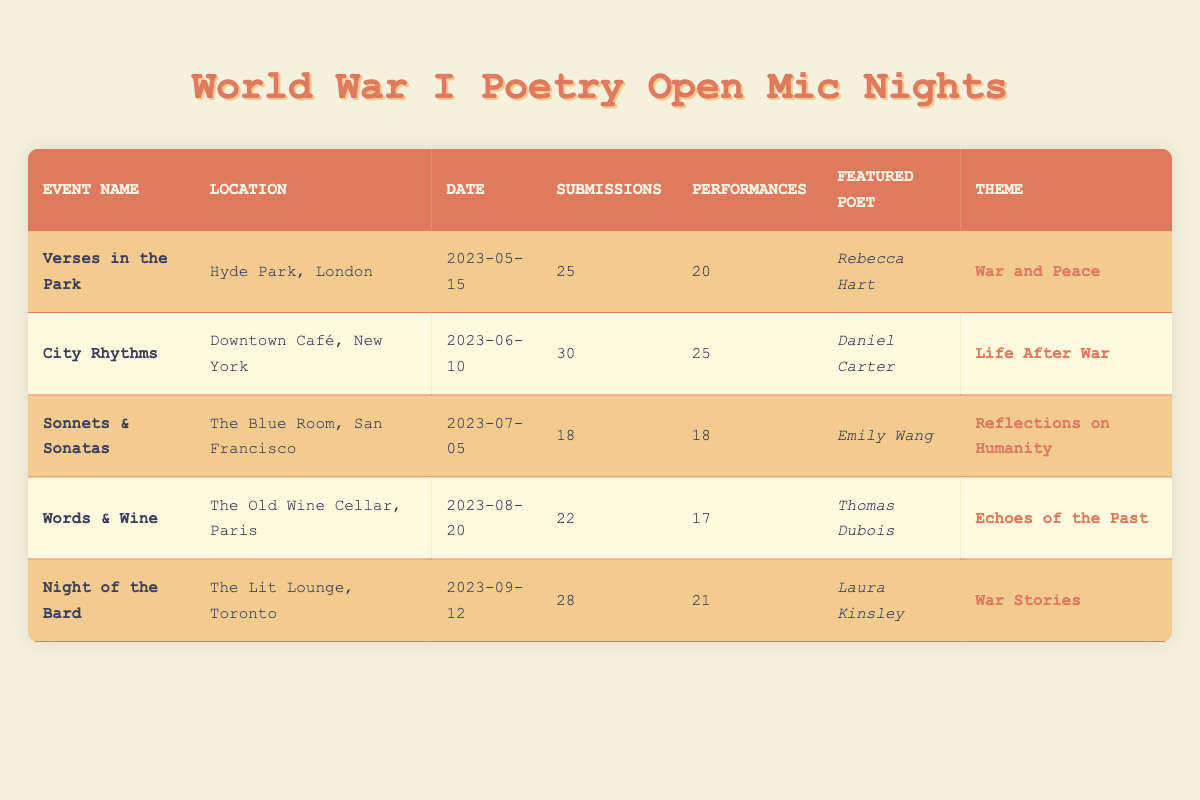What is the date of the "Sonnets & Sonatas" event? The table lists the event name "Sonnets & Sonatas", and looking at the corresponding cell in the date column reveals that it took place on "2023-07-05".
Answer: 2023-07-05 Which event had the highest number of poetry submissions? By comparing the poetry submissions column across all events, "City Rhythms" has the highest submissions with a total of 30.
Answer: City Rhythms How many performances occurred at the "Words & Wine" event? Looking at the specific row for the "Words & Wine" event, the performances column shows that there were 17 performances.
Answer: 17 What is the average number of poetry submissions among all events? To find the average, sum the poetry submissions: 25 + 30 + 18 + 22 + 28 = 123. Since there are 5 events, the average is 123 divided by 5, which equals 24.6.
Answer: 24.6 Did the "Night of the Bard" have more submissions than performances? Examining the submissions and performances for "Night of the Bard", it had 28 submissions and 21 performances, indicating that submissions were greater than performances.
Answer: Yes Which theme was featured at the "Verses in the Park" event? By looking at the row for "Verses in the Park", the theme column reveals that the theme was "War and Peace."
Answer: War and Peace How many events had more performances than submissions? Assessing each event, only "Words & Wine" has fewer performances (17) than submissions (22). The other events either had equal or more performances than submissions. Thus, the count is 1.
Answer: 1 Name the featured poet at the event with the theme "Life After War." In the table, you can see that the event "City Rhythms" corresponds to the theme "Life After War," and the featured poet for that event is Daniel Carter.
Answer: Daniel Carter Which event had the lowest number of performances? Checking each row's performances column, "Words & Wine" has the lowest number of performances recorded, which is 17.
Answer: Words & Wine 